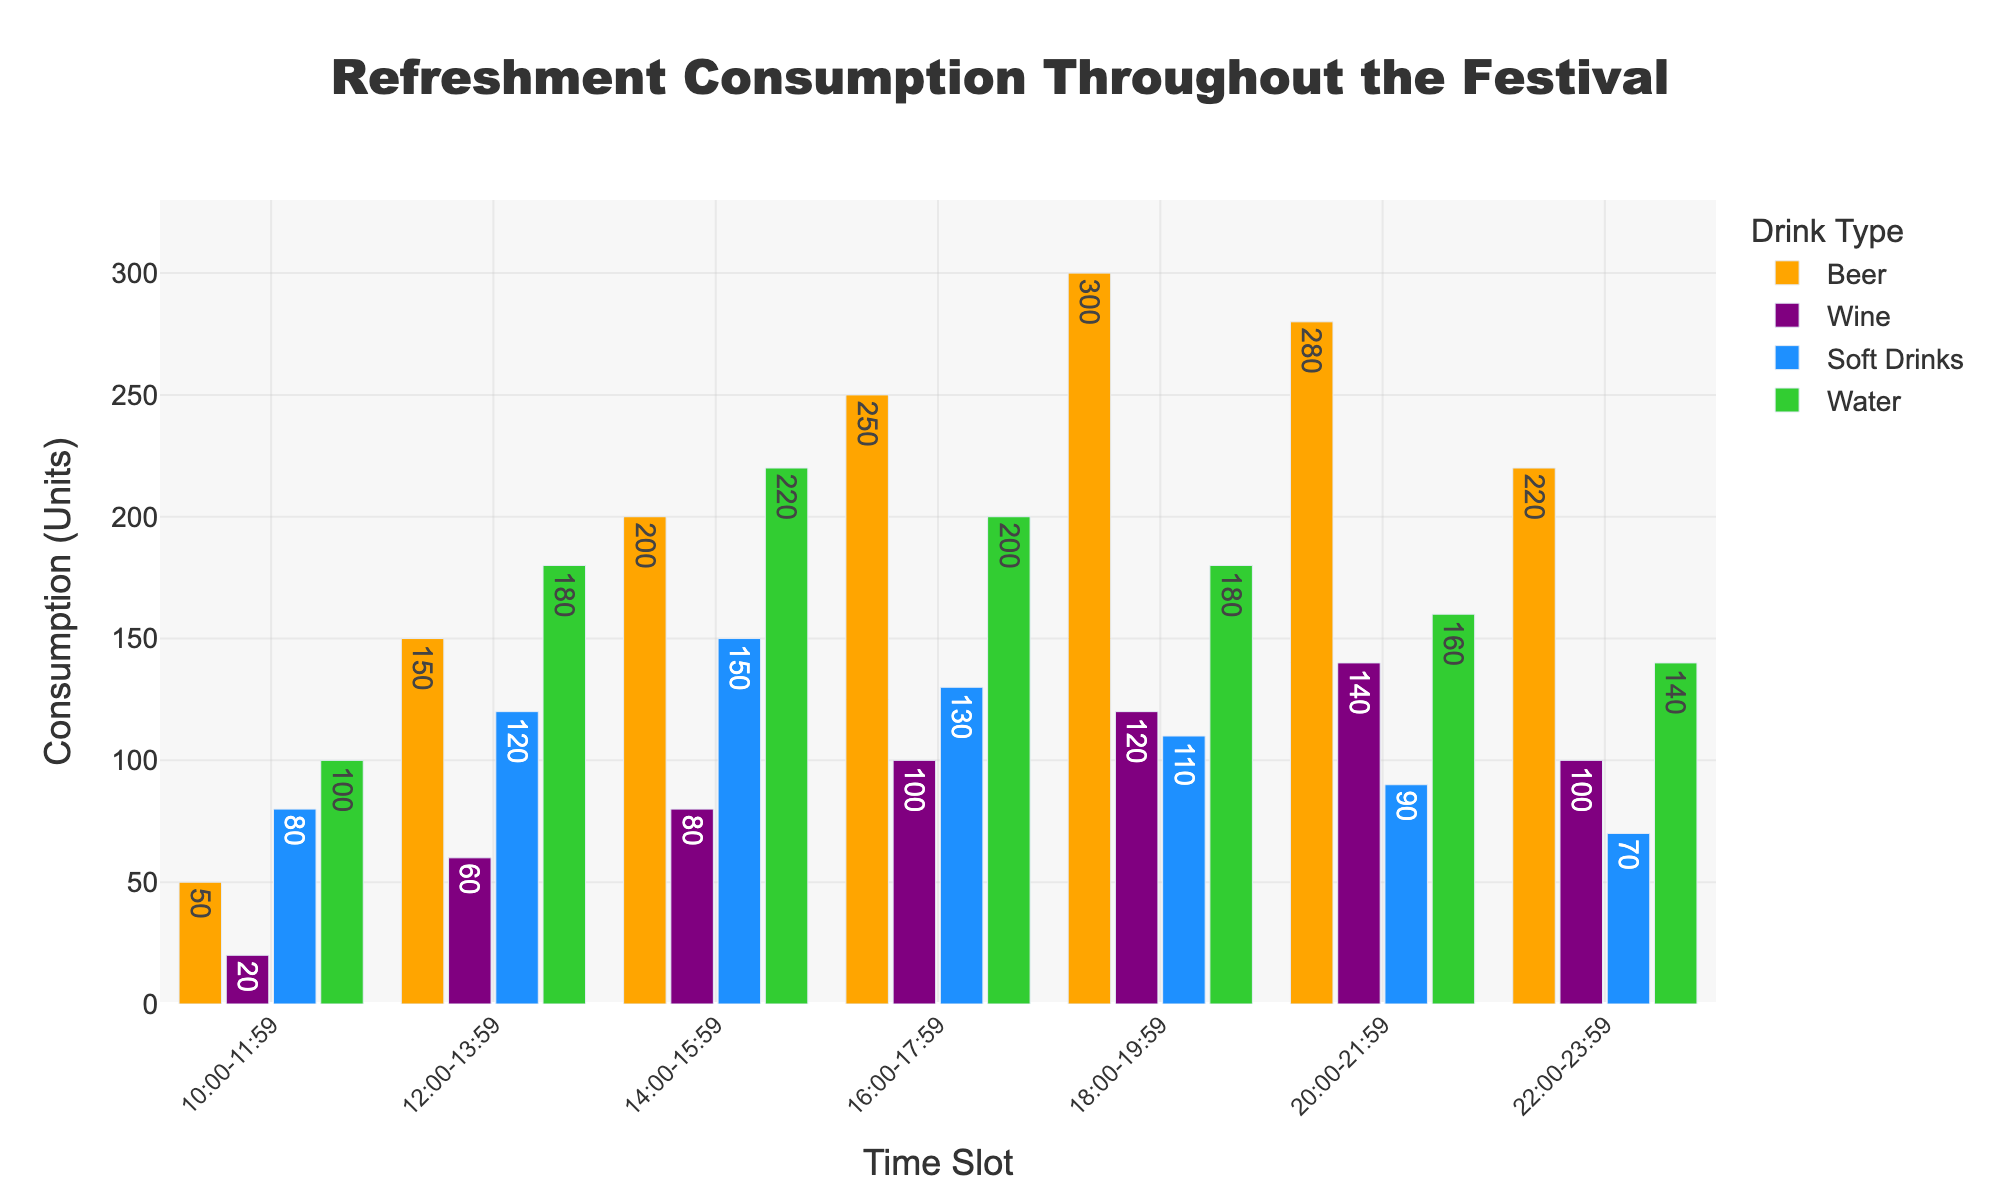What is the highest consumption of Beer during the festival? To find the highest consumption of Beer, look at the tallest bar among the bars representing Beer in different time slots. The bar representing Beer from 18:00-19:59 is the tallest.
Answer: 300 During which time slot does Wine consumption peak? To find when Wine consumption peaks, identify the tallest bar in the Wine category, which is colored purple. The peak occurs in the 20:00-21:59 time slot.
Answer: 20:00-21:59 Which drink has the lowest consumption in the 22:00-23:59 time slot? To find the lowest consumption in the 22:00-23:59 slot, compare the heights of all bars in this time slot. The "Soft Drinks" bar is the shortest in this time slot.
Answer: Soft Drinks What is the total consumption of all refreshments between 14:00-15:59? To find the total consumption between 14:00-15:59, sum the values for all drinks in that slot: 200 (Beer) + 80 (Wine) + 150 (Soft Drinks) + 220 (Water) = 650.
Answer: 650 Which time slot has the least total consumption of Soft Drinks? To identify the least total consumption of Soft Drinks, look for the shortest bar in the Soft Drinks category across all time slots. The shortest bar appears in the 22:00-23:59 slot.
Answer: 22:00-23:59 How much more Beer is consumed than Water during the 16:00-17:59 time slot? To find out how much more Beer is consumed than Water between 16:00-17:59, subtract the Water consumption from the Beer consumption in that slot: 250 - 200 = 50.
Answer: 50 Which time slot shows the highest total consumption of all refreshments combined? To determine the time slot with the highest total consumption, add the consumption values of all drinks for each slot and compare. The 14:00-15:59 slot has the highest total: 300 (Beer) + 120 (Wine) + 110 (Soft Drinks) + 220 (Water) = 750.
Answer: 14:00-15:59 What is the average consumption of Wine across all time slots? To find the average, sum the Wine values across all slots and divide by the number of slots. (20 + 60 + 80 + 100 + 120 + 140 + 100) / 7 = 620 / 7 ≈ 88.57.
Answer: 88.57 Which drink in the 12:00-13:59 time slot has the highest consumption? To identify the drink with the highest consumption in the 12:00-13:59 slot, compare the bar heights. The tallest bar in this slot is Water, with 180 units.
Answer: Water How does the consumption of Soft Drinks at 10:00-11:59 compare to the consumption at 18:00-19:59? To compare, look at the Soft Drinks consumption in both time slots. There are 80 units at 10:00-11:59 and 110 units at 18:00-19:59. Thus, consumption increases by 30 units.
Answer: Increases by 30 